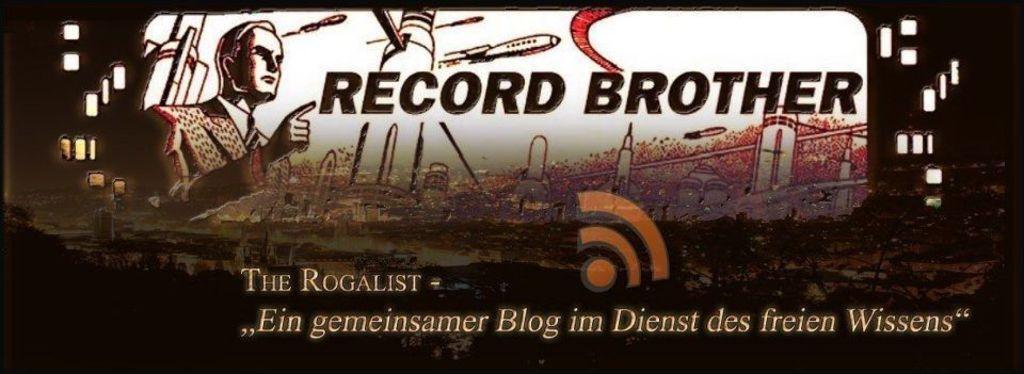Please provide a concise description of this image. In this image I can see a poster. There are words, there is a image of a person, there are images of buildings and there are some other images on it. 